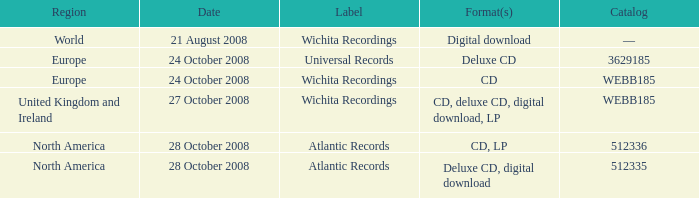Which region is associated with the catalog value of 512335? North America. 